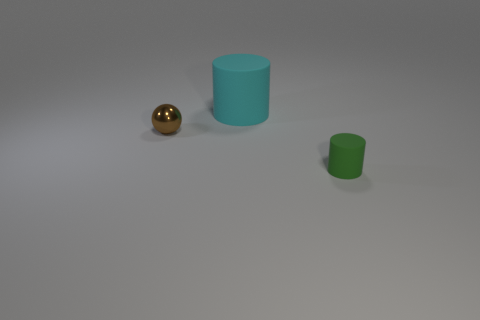There is a object that is behind the tiny rubber cylinder and right of the tiny metallic object; what is its color?
Keep it short and to the point. Cyan. There is a matte object behind the green object; is its size the same as the small brown thing?
Keep it short and to the point. No. Is there a small shiny ball that is behind the matte object behind the small brown ball?
Ensure brevity in your answer.  No. What material is the brown thing?
Provide a short and direct response. Metal. Are there any brown metallic spheres behind the big cylinder?
Your answer should be compact. No. The green object that is the same shape as the big cyan rubber thing is what size?
Provide a succinct answer. Small. Is the number of green objects in front of the big object the same as the number of cyan cylinders to the left of the small brown object?
Your answer should be very brief. No. How many gray metallic cylinders are there?
Keep it short and to the point. 0. Are there more cyan rubber things to the right of the tiny green matte cylinder than big red balls?
Provide a short and direct response. No. What is the small thing that is behind the small green thing made of?
Your response must be concise. Metal. 